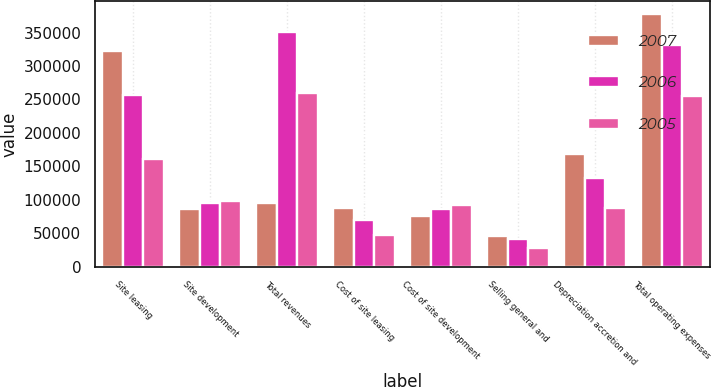Convert chart. <chart><loc_0><loc_0><loc_500><loc_500><stacked_bar_chart><ecel><fcel>Site leasing<fcel>Site development<fcel>Total revenues<fcel>Cost of site leasing<fcel>Cost of site development<fcel>Selling general and<fcel>Depreciation accretion and<fcel>Total operating expenses<nl><fcel>2007<fcel>321818<fcel>86383<fcel>94932<fcel>88006<fcel>75347<fcel>45569<fcel>169232<fcel>378154<nl><fcel>2006<fcel>256170<fcel>94932<fcel>351102<fcel>70663<fcel>85923<fcel>42277<fcel>133088<fcel>331594<nl><fcel>2005<fcel>161277<fcel>98714<fcel>259991<fcel>47259<fcel>92693<fcel>28178<fcel>87218<fcel>255796<nl></chart> 